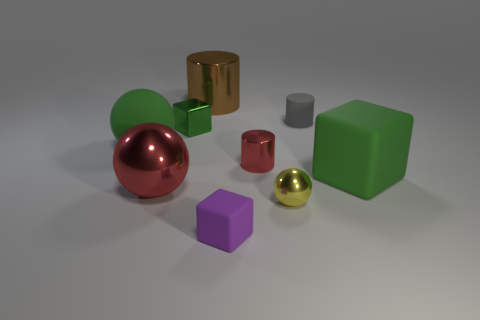Add 1 big gray blocks. How many objects exist? 10 Subtract all cubes. How many objects are left? 6 Subtract 0 red blocks. How many objects are left? 9 Subtract all big shiny balls. Subtract all tiny purple matte cubes. How many objects are left? 7 Add 8 big red balls. How many big red balls are left? 9 Add 5 tiny spheres. How many tiny spheres exist? 6 